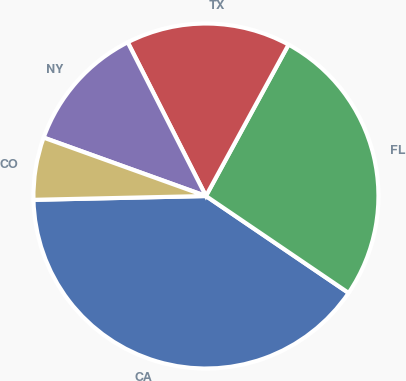Convert chart to OTSL. <chart><loc_0><loc_0><loc_500><loc_500><pie_chart><fcel>CA<fcel>FL<fcel>TX<fcel>NY<fcel>CO<nl><fcel>40.15%<fcel>26.55%<fcel>15.44%<fcel>12.01%<fcel>5.85%<nl></chart> 